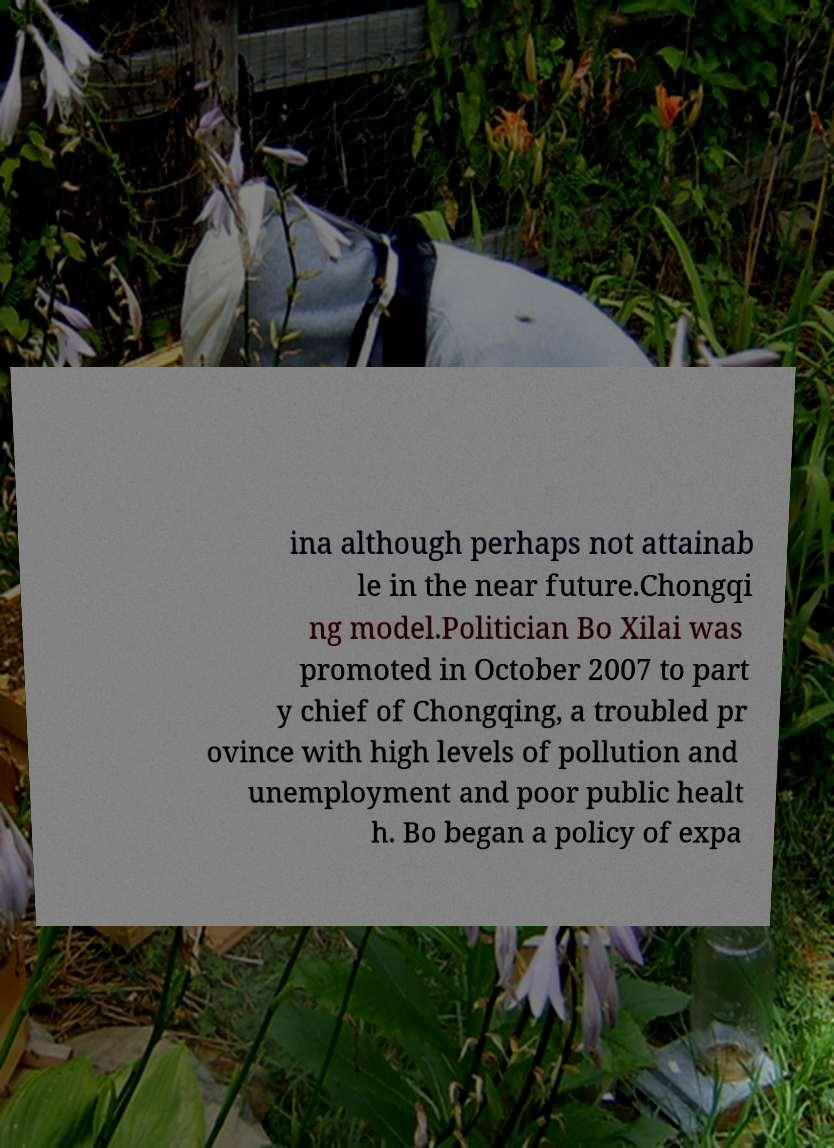There's text embedded in this image that I need extracted. Can you transcribe it verbatim? ina although perhaps not attainab le in the near future.Chongqi ng model.Politician Bo Xilai was promoted in October 2007 to part y chief of Chongqing, a troubled pr ovince with high levels of pollution and unemployment and poor public healt h. Bo began a policy of expa 